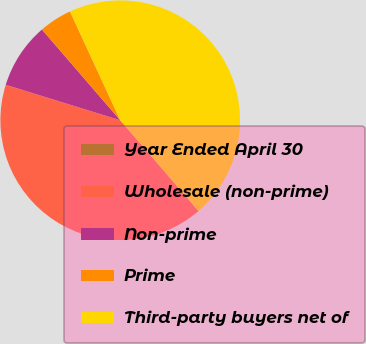Convert chart to OTSL. <chart><loc_0><loc_0><loc_500><loc_500><pie_chart><fcel>Year Ended April 30<fcel>Wholesale (non-prime)<fcel>Non-prime<fcel>Prime<fcel>Third-party buyers net of<nl><fcel>0.0%<fcel>41.11%<fcel>8.89%<fcel>4.44%<fcel>45.55%<nl></chart> 